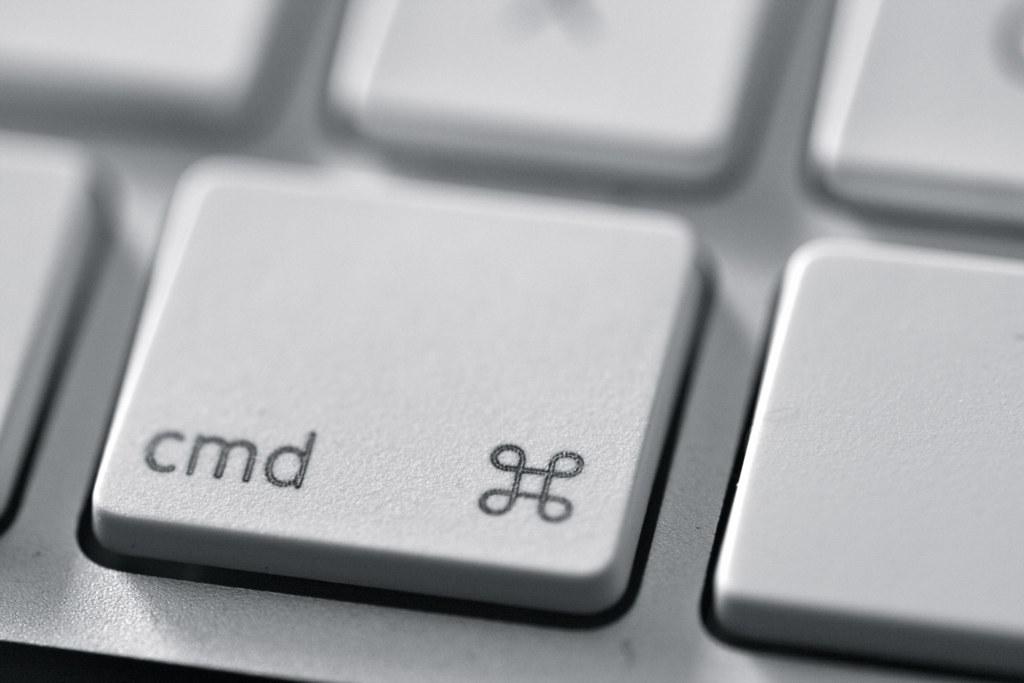What are the letters on this button?
Your response must be concise. Cmd. 